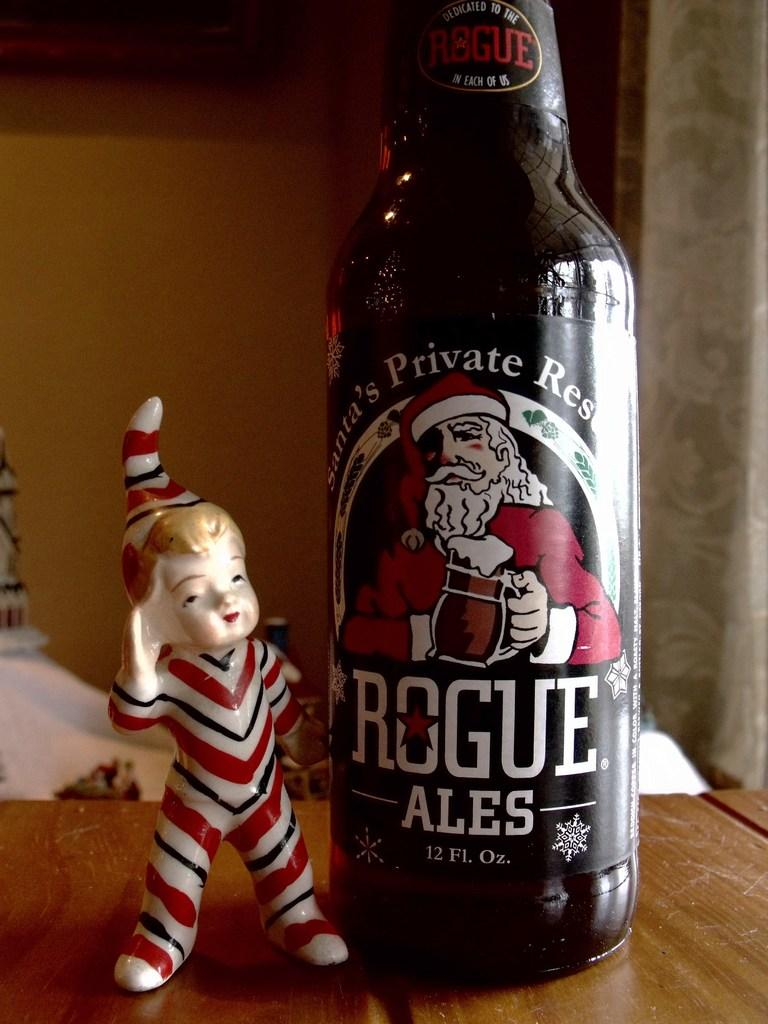<image>
Relay a brief, clear account of the picture shown. A bottle of Rogue is on a desk next to a boy figurine. 